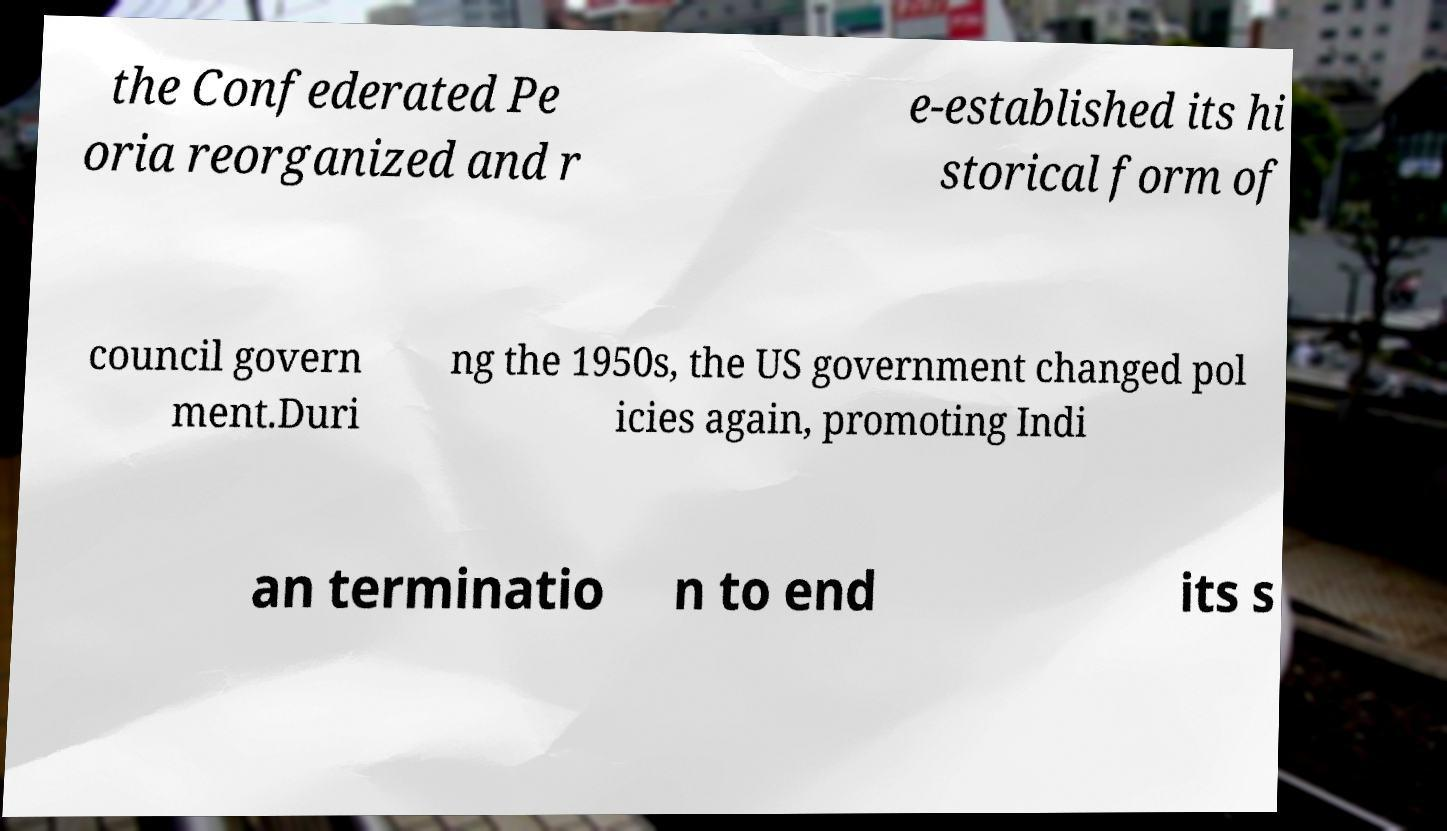Please read and relay the text visible in this image. What does it say? the Confederated Pe oria reorganized and r e-established its hi storical form of council govern ment.Duri ng the 1950s, the US government changed pol icies again, promoting Indi an terminatio n to end its s 